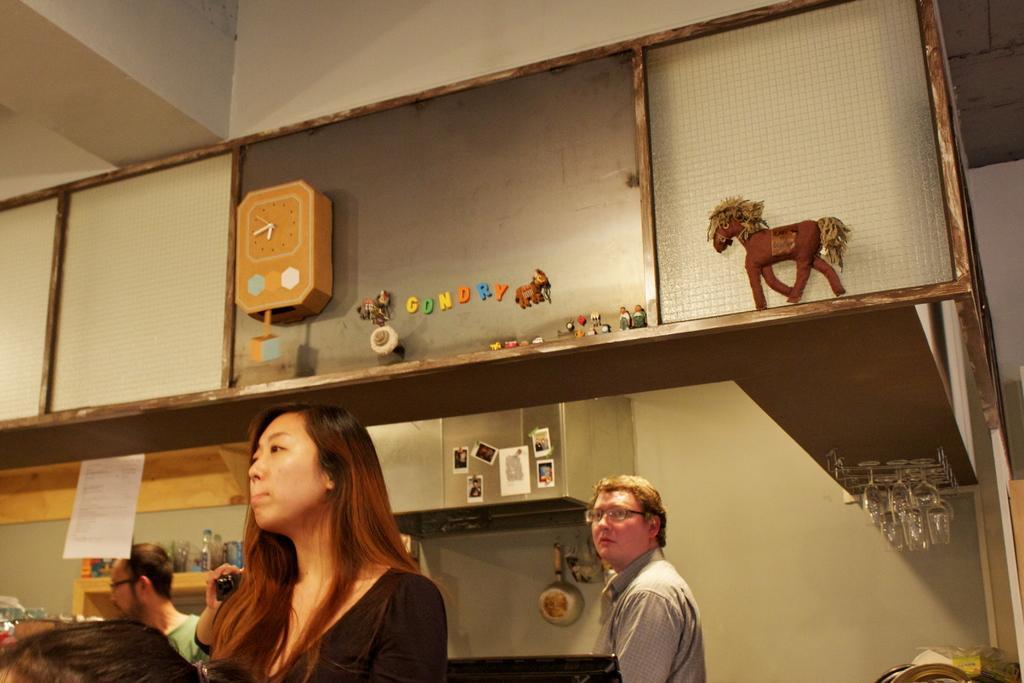Describe this image in one or two sentences. At the bottom of the picture there are people, bottles, wall and other objects. In the center of the picture there are glasses, ventilator, stickers, pans, paper and other objects. At the top there are clock, toys and wall. 